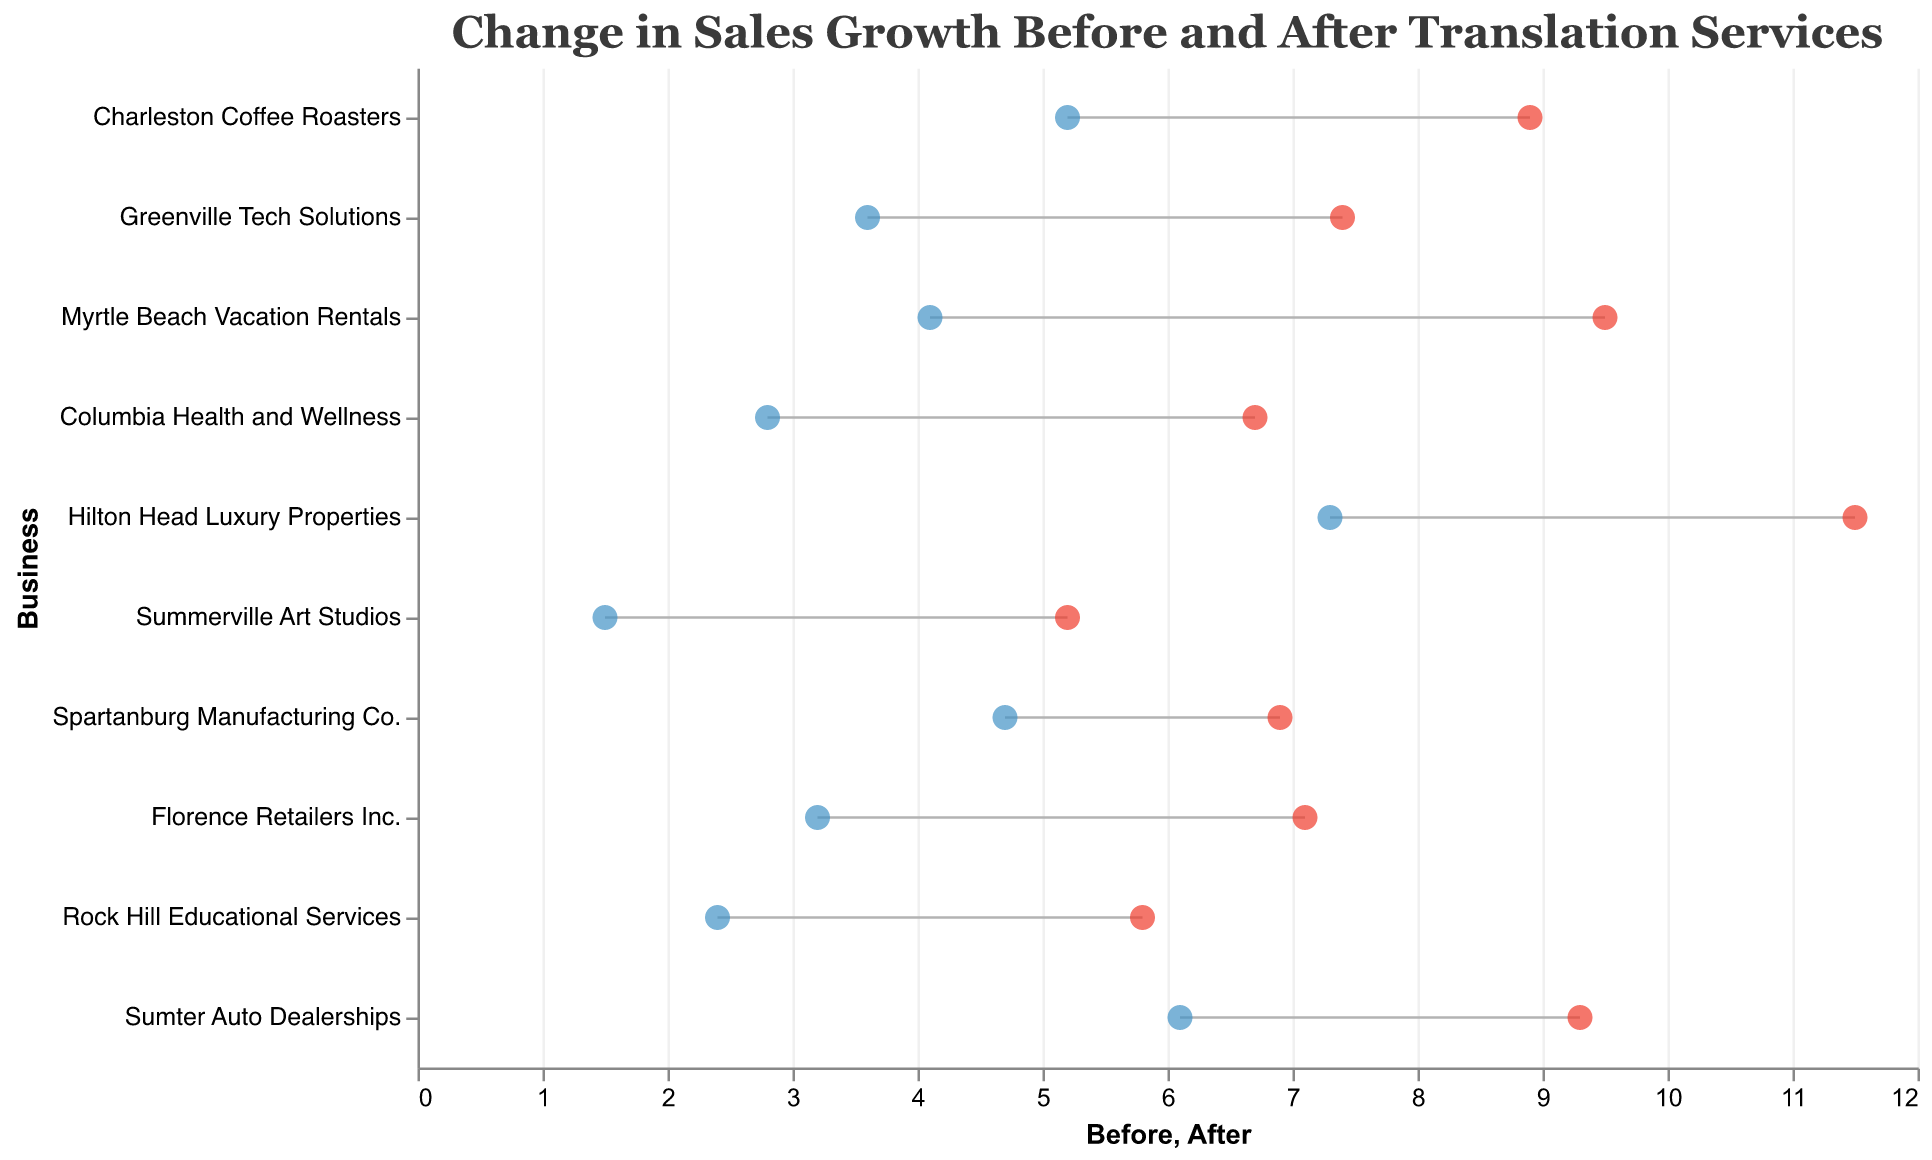What's the title of the figure? The title of the figure is usually found at the top and gives an overview of what the chart is about. It helps set the context for the data being visualized. In this case, it is clearly stated at the top of the figure.
Answer: Change in Sales Growth Before and After Translation Services How many businesses are represented in the figure? By counting the number of distinct businesses listed on the vertical axis, we can determine the number of businesses represented in the figure. Each business name appears as a separate entry.
Answer: 10 Which business had the highest sales growth after implementing translation services? To determine this, we need to look at the values for "Sales Growth After (%)" and find the highest value. The corresponding business for this value will be our answer. "Hilton Head Luxury Properties" has the highest sales growth after implementation, marked at 11.5%.
Answer: Hilton Head Luxury Properties What is the difference in sales growth before and after implementing translation services for Charleston Coffee Roasters? Calculate the difference by subtracting the "Sales Growth Before (%)" value from the "Sales Growth After (%)" value for Charleston Coffee Roasters: 8.9 - 5.2.
Answer: 3.7% Which industry saw the smallest change in sales growth after implementing translation services? To find the industry with the smallest change, calculate the difference for each business and determine the smallest value. The values are: Charleston Coffee Roasters (3.7), Greenville Tech Solutions (3.8), Myrtle Beach Vacation Rentals (5.4), Columbia Health and Wellness (3.9), Hilton Head Luxury Properties (4.2), Summerville Art Studios (3.7), Spartanburg Manufacturing Co. (2.2), Florence Retailers Inc. (3.9), Rock Hill Educational Services (3.4), and Sumter Auto Dealerships (3.2). The smallest is for Spartanburg Manufacturing Co.
Answer: Manufacturing Which two businesses had the same change in sales growth? Calculate the change for each business similarly and compare values to find any that match. Both Charleston Coffee Roasters and Summerville Art Studios have a change in sales growth of 3.7%.
Answer: Charleston Coffee Roasters and Summerville Art Studios What are the average sales growth values before and after implementing translation services? To find these averages, sum all the "Sales Growth Before (%)" values and then all the "Sales Growth After (%)" values, and divide each sum by the number of businesses (10). Before: (5.2 + 3.6 + 4.1 + 2.8 + 7.3 + 1.5 + 4.7 + 3.2 + 2.4 + 6.1)/10 = 41.9/10 = 4.19. After: (8.9 + 7.4 + 9.5 + 6.7 + 11.5 + 5.2 + 6.9 + 7.1 + 5.8 + 9.3)/10 = 78.3/10 = 7.83.
Answer: 4.19% and 7.83% Which business had the greatest increase in sales growth percentage points after implementing translation services? Calculate the difference between "Sales Growth Before (%)" and "Sales Growth After (%)" for each business and find the maximum difference. For example, Myrtle Beach Vacation Rentals has a difference of 9.5 - 4.1 = 5.4, which is the greatest compared to others.
Answer: Myrtle Beach Vacation Rentals What is the median sales growth after implementing translation services? To find the median, first, list all "Sales Growth After (%)" values in numerical order: (5.2, 5.8, 6.7, 6.9, 7.1, 7.4, 8.9, 9.3, 9.5, 11.5). With 10 values, the median is the average of the 5th and 6th values: (7.1 + 7.4) / 2 = 7.25.
Answer: 7.25% 